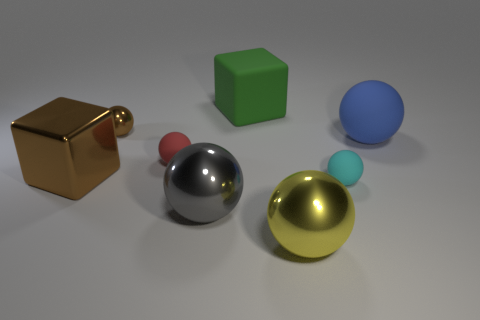What can you infer about the material properties of these objects based on their appearance? Based on their appearance, the objects seem to exhibit different material qualities. The gold cube and the silver and golden-yellow spheres have reflective surfaces that suggest they are metallic. In contrast, the green cube and the small blue sphere behind the silver sphere appear matte, indicating a non-reflective surface, which could be made of plastic or painted with a non-glossy finish. 